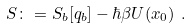Convert formula to latex. <formula><loc_0><loc_0><loc_500><loc_500>S \colon = S _ { b } [ q _ { b } ] - \hbar { \beta } U ( x _ { 0 } ) \ .</formula> 